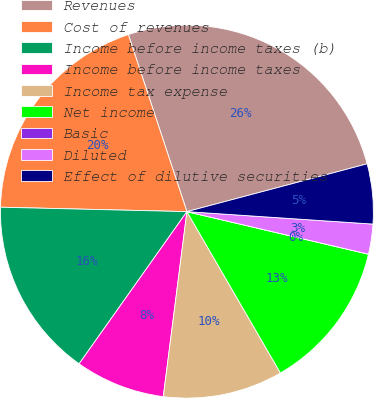Convert chart to OTSL. <chart><loc_0><loc_0><loc_500><loc_500><pie_chart><fcel>Revenues<fcel>Cost of revenues<fcel>Income before income taxes (b)<fcel>Income before income taxes<fcel>Income tax expense<fcel>Net income<fcel>Basic<fcel>Diluted<fcel>Effect of dilutive securities<nl><fcel>25.96%<fcel>19.54%<fcel>15.57%<fcel>7.79%<fcel>10.38%<fcel>12.98%<fcel>0.0%<fcel>2.6%<fcel>5.19%<nl></chart> 